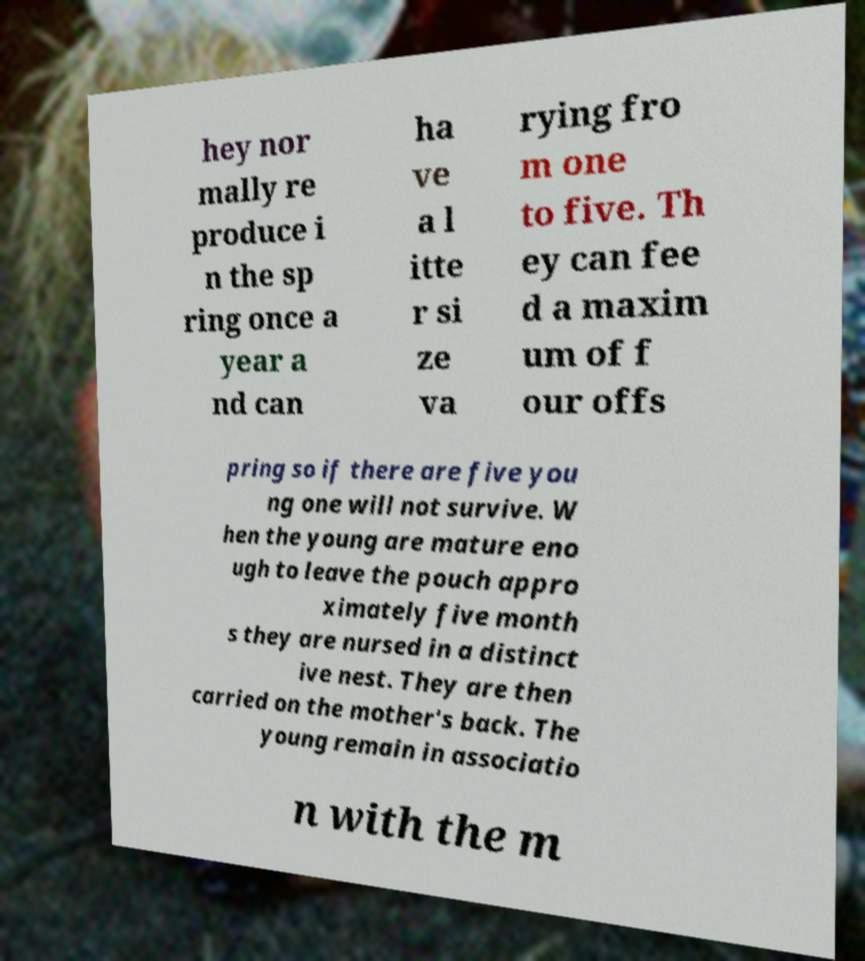For documentation purposes, I need the text within this image transcribed. Could you provide that? hey nor mally re produce i n the sp ring once a year a nd can ha ve a l itte r si ze va rying fro m one to five. Th ey can fee d a maxim um of f our offs pring so if there are five you ng one will not survive. W hen the young are mature eno ugh to leave the pouch appro ximately five month s they are nursed in a distinct ive nest. They are then carried on the mother's back. The young remain in associatio n with the m 